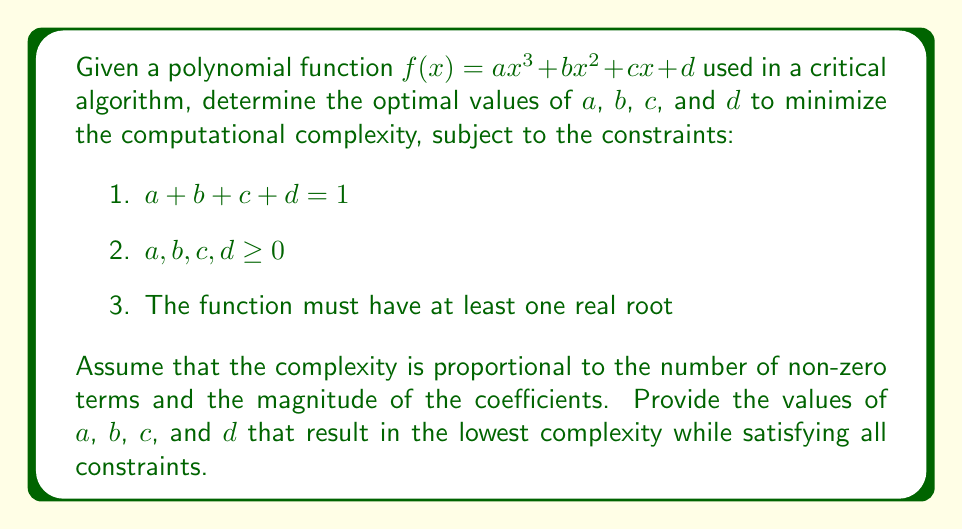Provide a solution to this math problem. To minimize computational complexity, we need to:
1. Minimize the number of non-zero terms
2. Minimize the magnitude of the coefficients

Step 1: Analyze the constraints
- The first constraint ensures that the sum of all coefficients is 1
- The second constraint restricts coefficients to non-negative values
- The third constraint requires at least one real root

Step 2: Minimize non-zero terms
To minimize the number of non-zero terms, we should aim for as many zero coefficients as possible while still satisfying the constraints.

Step 3: Consider the lowest degree polynomial
A linear function ($ax + d$) is the lowest degree polynomial that can have a real root. This satisfies the third constraint while minimizing the number of terms.

Step 4: Optimize coefficients
To minimize the magnitude of coefficients while satisfying the first constraint:
$a + d = 1$, where $a, d \geq 0$

The optimal solution is $a = d = 0.5$, as this evenly distributes the value between the two coefficients.

Step 5: Verify all constraints
- $a + b + c + d = 0.5 + 0 + 0 + 0.5 = 1$ (satisfies constraint 1)
- All coefficients are non-negative (satisfies constraint 2)
- The function $f(x) = 0.5x + 0.5$ has a real root at $x = -1$ (satisfies constraint 3)

Therefore, the optimal polynomial function is $f(x) = 0.5x + 0.5$, with $a = 0.5$, $b = 0$, $c = 0$, and $d = 0.5$.
Answer: $a = 0.5$, $b = 0$, $c = 0$, $d = 0.5$ 